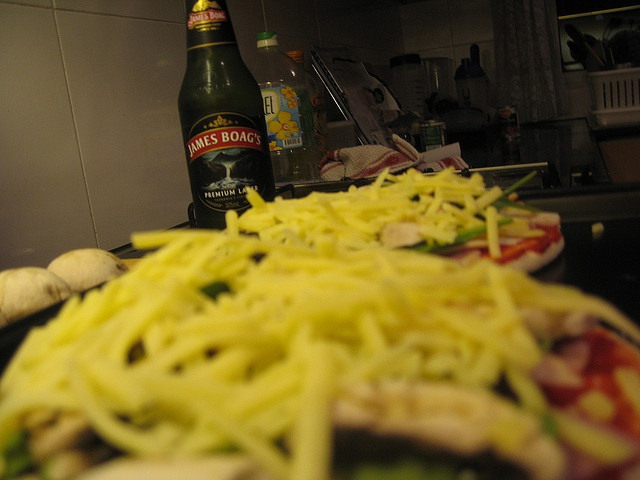Describe the objects in this image and their specific colors. I can see pizza in darkgreen, olive, and gold tones, pizza in darkgreen, gold, and olive tones, bottle in darkgreen, black, maroon, and olive tones, and bottle in darkgreen, black, olive, and gray tones in this image. 